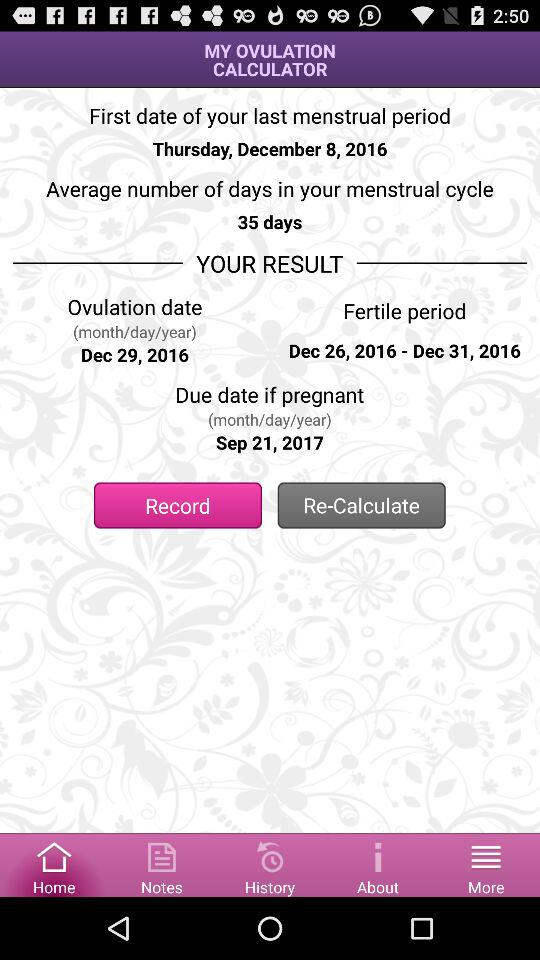What is the due date? The due date is September 21, 2017. 